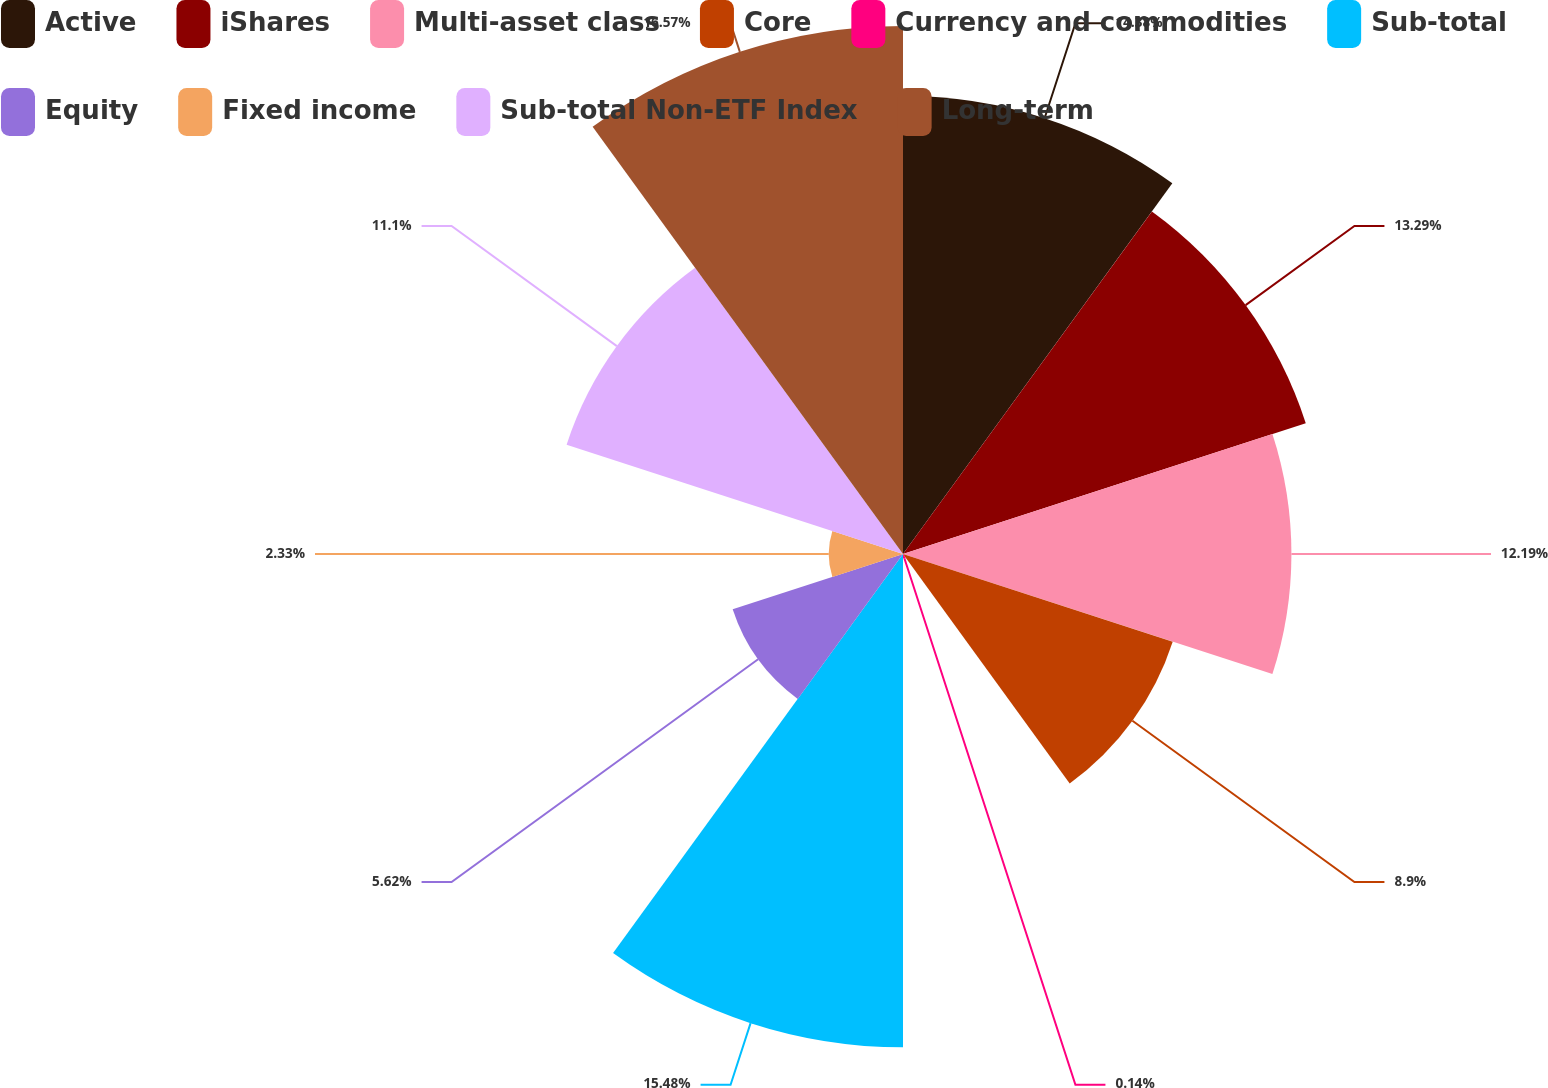Convert chart. <chart><loc_0><loc_0><loc_500><loc_500><pie_chart><fcel>Active<fcel>iShares<fcel>Multi-asset class<fcel>Core<fcel>Currency and commodities<fcel>Sub-total<fcel>Equity<fcel>Fixed income<fcel>Sub-total Non-ETF Index<fcel>Long-term<nl><fcel>14.38%<fcel>13.29%<fcel>12.19%<fcel>8.9%<fcel>0.14%<fcel>15.48%<fcel>5.62%<fcel>2.33%<fcel>11.1%<fcel>16.57%<nl></chart> 